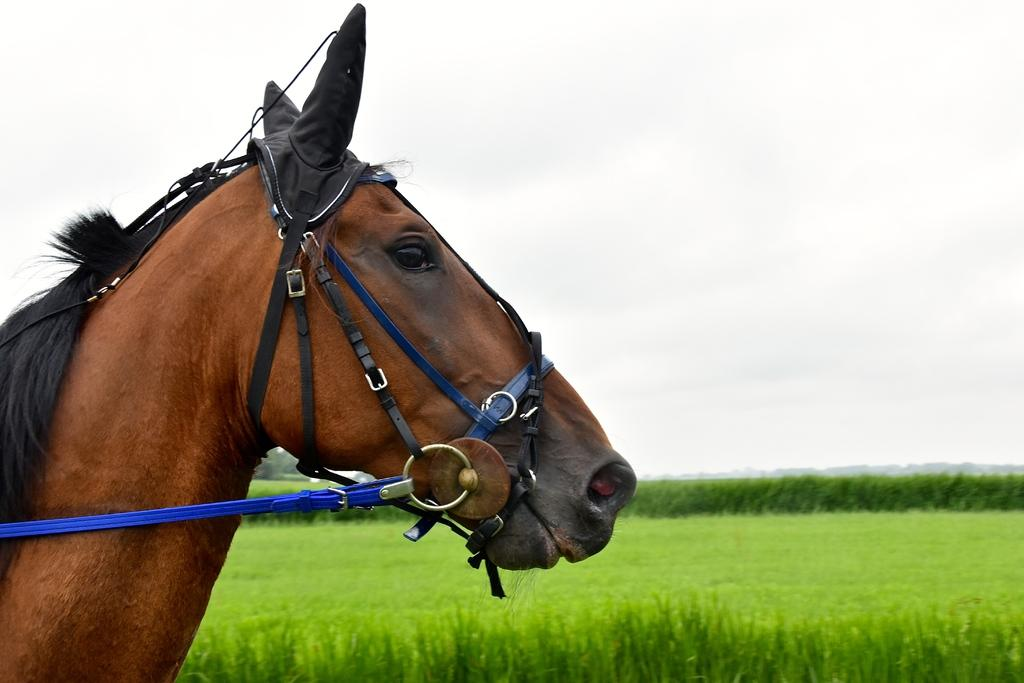What animal is on the left side of the image? There is a horse on the left side of the image. What is attached to the horse's face? A belt is tied to the horse's face. What can be seen in the background of the image? There are trees and clouds in the sky in the background of the image. What type of terrain is visible at the bottom of the image? The bottom of the image shows a field. How does the horse use the lock to secure its mind in the image? There is no lock present in the image, and horses do not have the ability to secure their minds. 